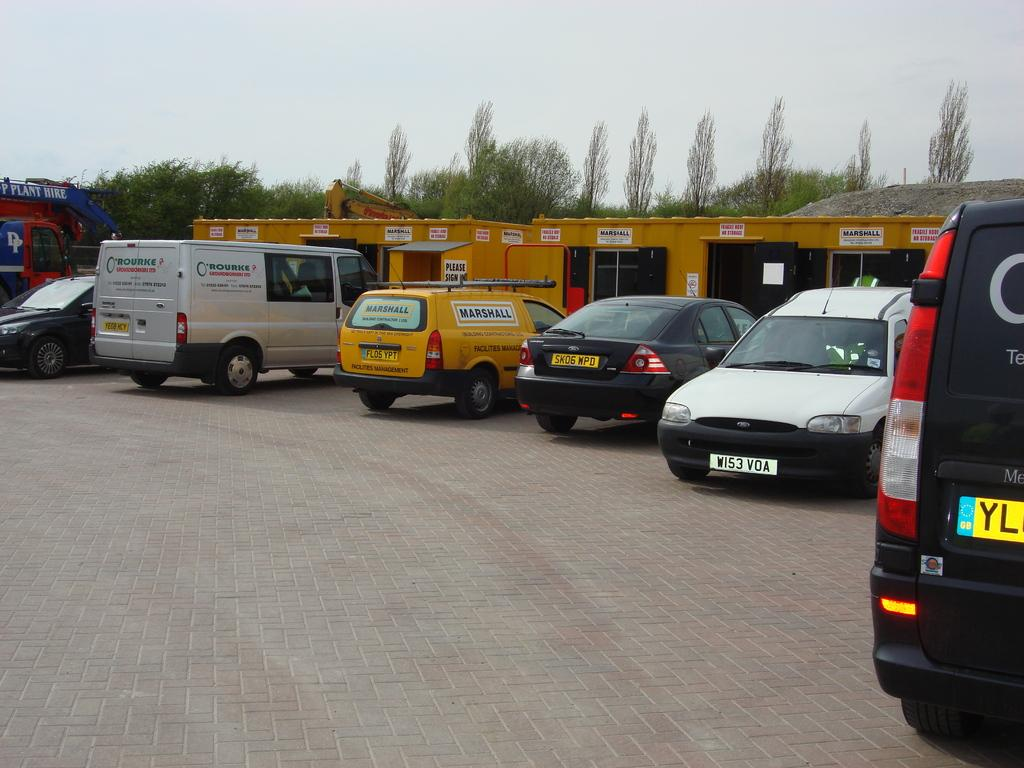Provide a one-sentence caption for the provided image. A row of vehicles are parked by yellow sipping containers that say Marshall. 